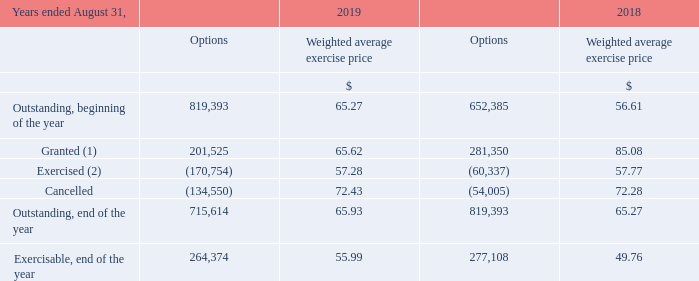D) SHARE-BASED PAYMENT PLANS
The Corporation offers an Employee Stock Purchase Plan for the benefit of its employees and those of its subsidiaries and a Stock Option Plan to its executive officers and designated employees. No more than 10% of the outstanding subordinate voting shares are available for issuance under these plans. Furthermore, the Corporation offers an Incentive Share Unit Plan ("ISU Plan") and a Performance Share Unit Plan ("PSU Plan") for executive officers and designated employees, and a Deferred Share Unit Plan ("DSU Plan") for members of the Board of Directors ("Board").
Stock purchase plan The Corporation offers, for the benefit of its employees and those of its subsidiaries, an Employee Stock Purchase Plan, which is accessible to all employees up to a maximum of 7% of their base annual salary and the Corporation contributes 25% of the employee contributions. The subscriptions are made monthly and employee subordinate voting shares are purchased on the stock market.
Stock option plan A total of 3,432,500 subordinate voting shares are reserved for the purpose of the Stock Option Plan. The minimum exercise price at which options are granted is equal to the market value of such shares at the time the option is granted. Options vest equally over a period of five years beginning one year after the day such options are granted and are exercisable over ten years.
Under the Stock Option Plan, the following options were granted by the Corporation and are outstanding at August 31:
(1) For the year ended August 31, 2019, the Corporation granted 97,725 (126,425 in 2018) stock options to Cogeco's executive officers as executive officers of the Corporation. (2) The weighted average share price for options exercised during the year was $92.43 ($83.46 in 2018).
What percentage of outstanding subordinate shares are available for issuance under the corporation offer? 10%. What maximum percentage of employee's base annual salary can be used for Employee Stock Purchase Plan? 7%. What is the total number of shares under Stock option plan A? 3,432,500 subordinate voting shares. What is the increase / (decrease) in the Options Outstanding, beginning of the year shares from 2018 to 2019? 819,393 - 652,385
Answer: 167008. What is the average options granted from 2018 to 2019? (201,525 + 281,350) / 2
Answer: 241437.5. What is the average Outstanding, end of the year options from 2018 to 2019? (715,614 + 819,393) / 2
Answer: 767503.5. 